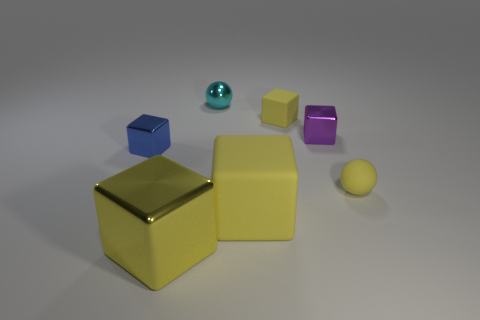Add 1 tiny matte things. How many objects exist? 8 Subtract all yellow blocks. How many blocks are left? 2 Subtract all blocks. How many objects are left? 2 Add 5 yellow cylinders. How many yellow cylinders exist? 5 Subtract all blue cubes. How many cubes are left? 4 Subtract 0 red cylinders. How many objects are left? 7 Subtract 1 blocks. How many blocks are left? 4 Subtract all brown spheres. Subtract all green blocks. How many spheres are left? 2 Subtract all yellow cubes. How many purple balls are left? 0 Subtract all large cubes. Subtract all tiny blue metal things. How many objects are left? 4 